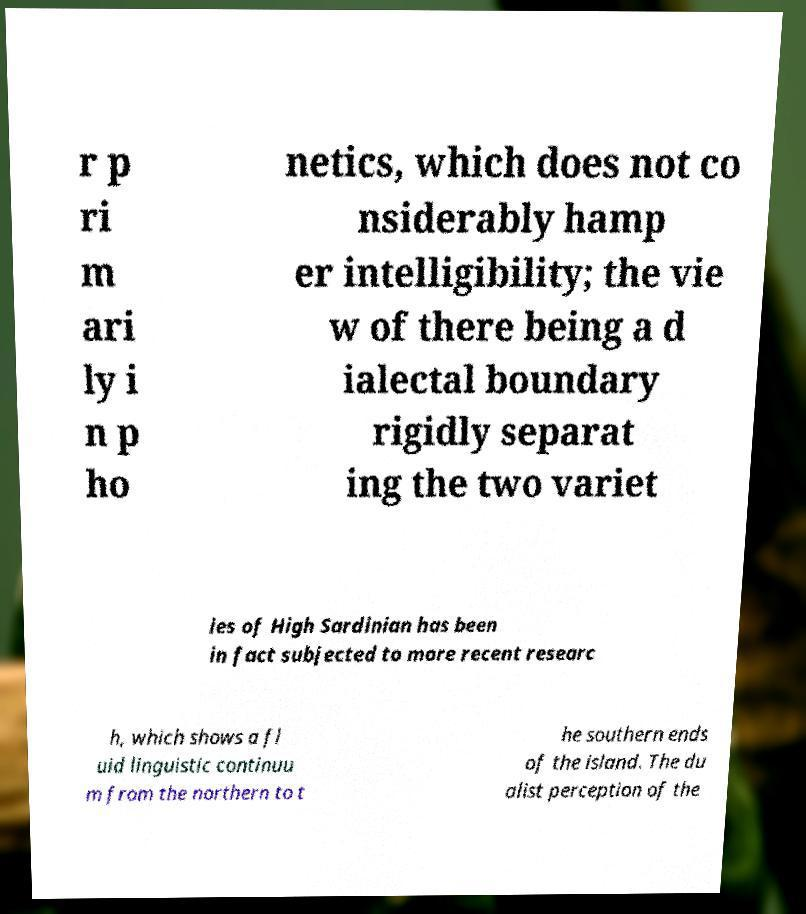Could you assist in decoding the text presented in this image and type it out clearly? r p ri m ari ly i n p ho netics, which does not co nsiderably hamp er intelligibility; the vie w of there being a d ialectal boundary rigidly separat ing the two variet ies of High Sardinian has been in fact subjected to more recent researc h, which shows a fl uid linguistic continuu m from the northern to t he southern ends of the island. The du alist perception of the 